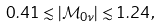Convert formula to latex. <formula><loc_0><loc_0><loc_500><loc_500>0 . 4 1 \lesssim | \mathcal { M } _ { 0 \nu } | \lesssim 1 . 2 4 \, ,</formula> 